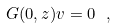Convert formula to latex. <formula><loc_0><loc_0><loc_500><loc_500>G ( 0 , z ) v = 0 \ ,</formula> 